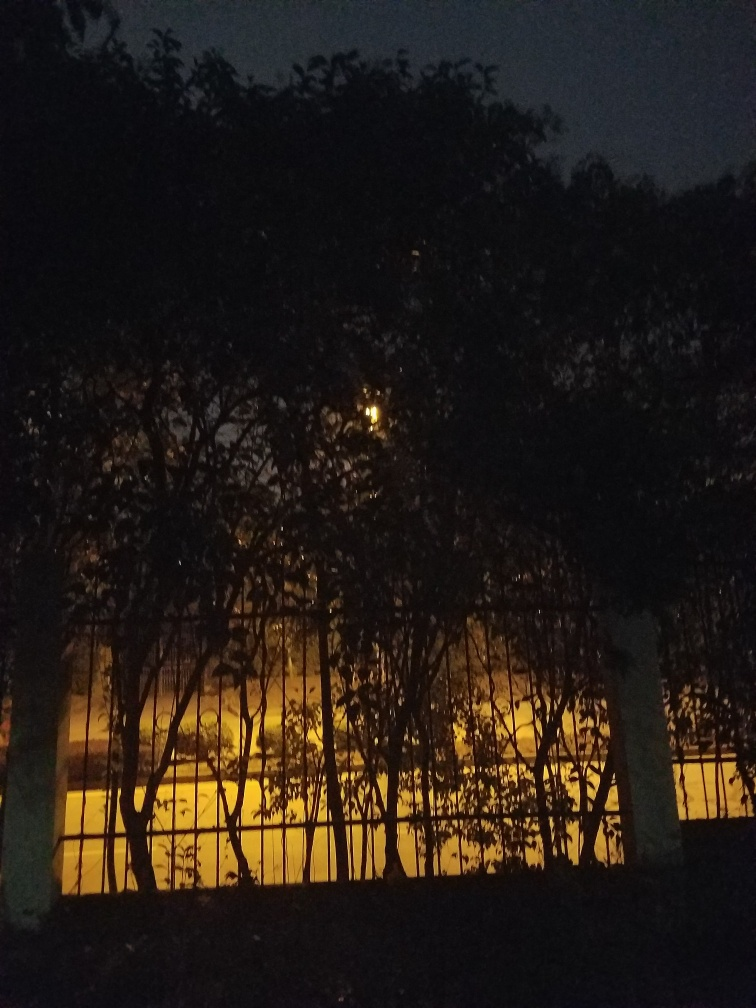Does the image have any quality issues that are not mentioned in the analysis? The image is relatively dark, making it challenging to discern fine details. The photo appears to be taken at twilight or night with minimal ambient light except for the warm glow coming from a light source behind the trees. There could be potential graininess due to the low-light conditions and the dynamic range is limited, with the darkness possibly swallowing finer details. These factors collectively impact the overall clarity and quality of the image. 